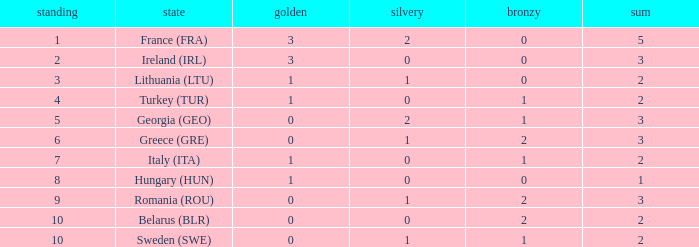What's the total number of bronze medals for Sweden (SWE) having less than 1 gold and silver? 0.0. 